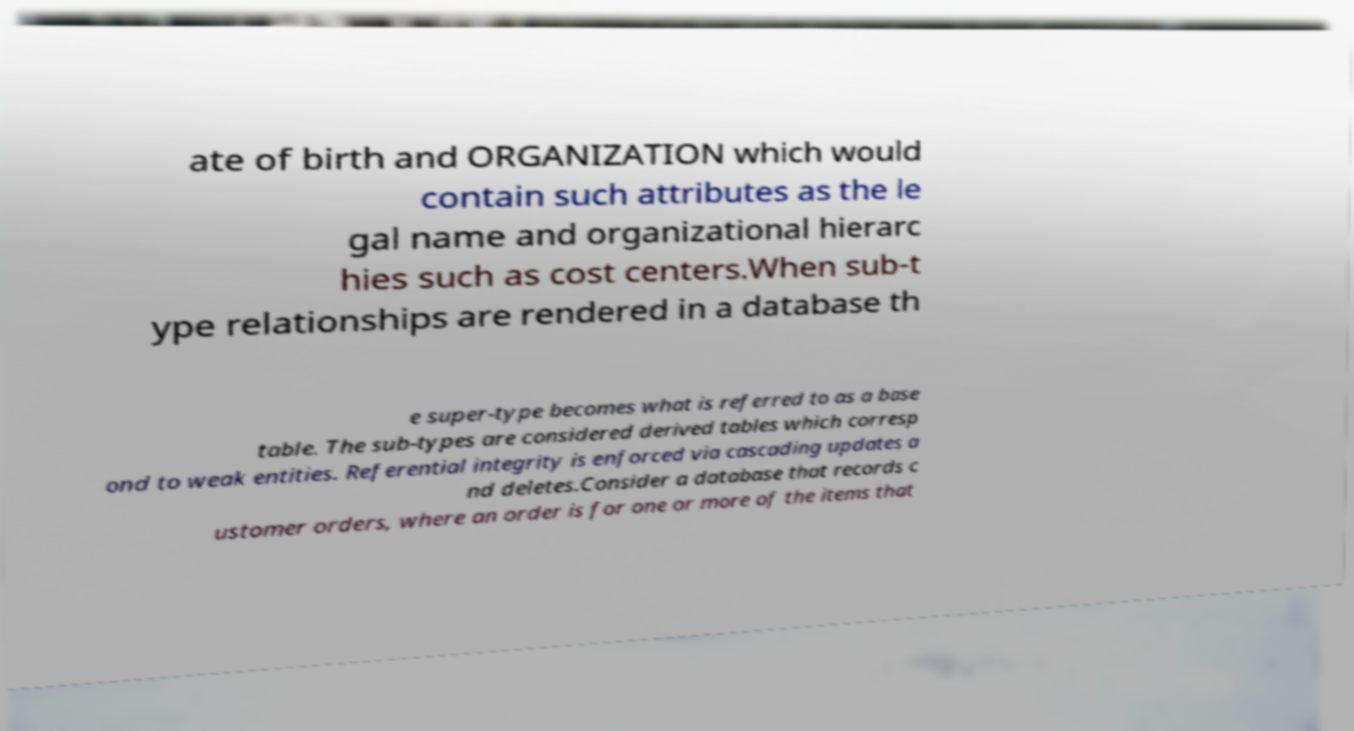Could you assist in decoding the text presented in this image and type it out clearly? ate of birth and ORGANIZATION which would contain such attributes as the le gal name and organizational hierarc hies such as cost centers.When sub-t ype relationships are rendered in a database th e super-type becomes what is referred to as a base table. The sub-types are considered derived tables which corresp ond to weak entities. Referential integrity is enforced via cascading updates a nd deletes.Consider a database that records c ustomer orders, where an order is for one or more of the items that 